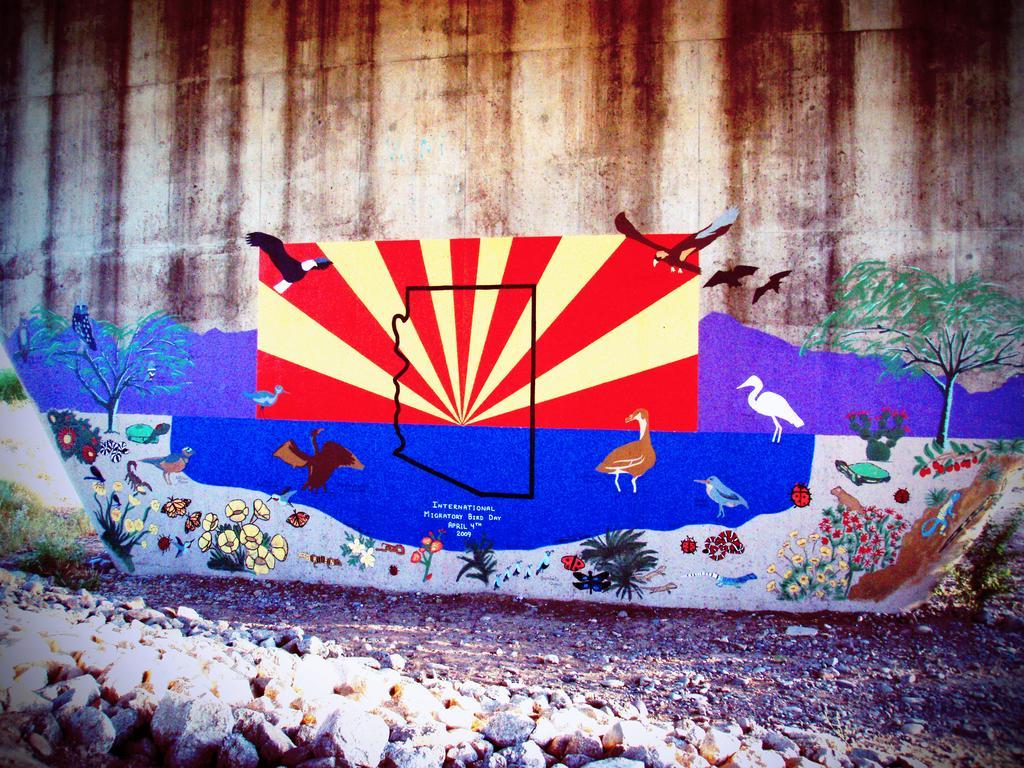In one or two sentences, can you explain what this image depicts? In this picture we can see a wall and on this wall there is a painting of birds flying, trees and some bugs, insects, flower plants and in front of this wall there is a land and rocks like stones one after the other. 